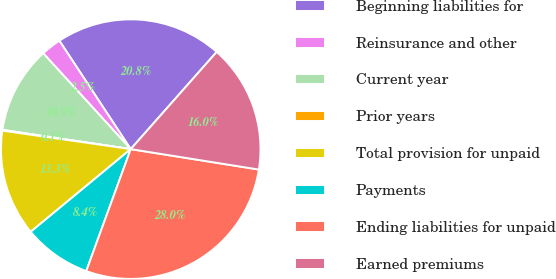<chart> <loc_0><loc_0><loc_500><loc_500><pie_chart><fcel>Beginning liabilities for<fcel>Reinsurance and other<fcel>Current year<fcel>Prior years<fcel>Total provision for unpaid<fcel>Payments<fcel>Ending liabilities for unpaid<fcel>Earned premiums<nl><fcel>20.79%<fcel>2.51%<fcel>10.85%<fcel>0.1%<fcel>13.27%<fcel>8.44%<fcel>28.05%<fcel>15.99%<nl></chart> 